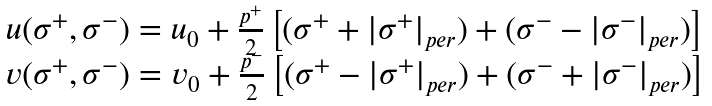Convert formula to latex. <formula><loc_0><loc_0><loc_500><loc_500>\begin{array} { c } u ( \sigma ^ { + } , \sigma ^ { - } ) = u _ { 0 } + \frac { p ^ { + } } 2 \left [ ( \sigma ^ { + } + \left | \sigma ^ { + } \right | _ { p e r } ) + ( \sigma ^ { - } - \left | \sigma ^ { - } \right | _ { p e r } ) \right ] \\ v ( \sigma ^ { + } , \sigma ^ { - } ) = v _ { 0 } + \frac { p ^ { - } } 2 \left [ ( \sigma ^ { + } - \left | \sigma ^ { + } \right | _ { p e r } ) + ( \sigma ^ { - } + \left | \sigma ^ { - } \right | _ { p e r } ) \right ] \end{array}</formula> 